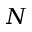<formula> <loc_0><loc_0><loc_500><loc_500>N</formula> 